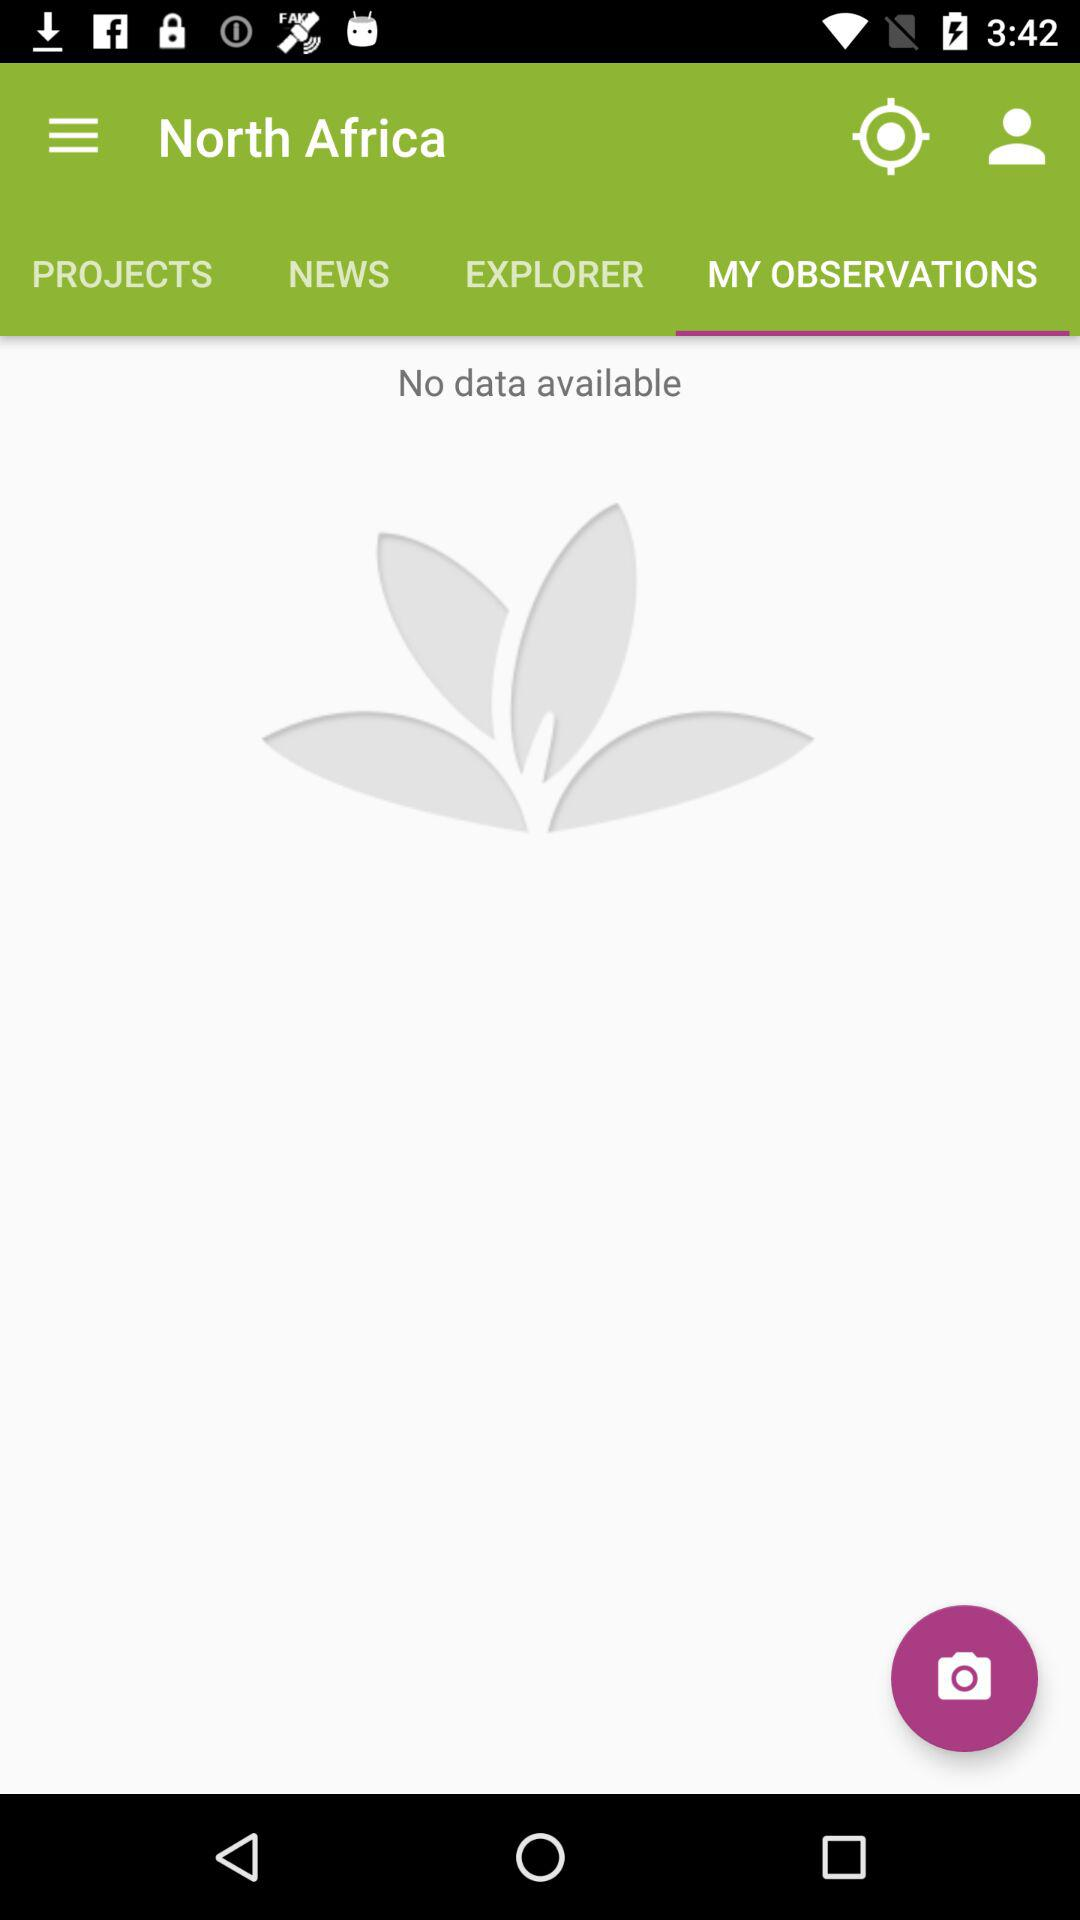What is the name of the user?
When the provided information is insufficient, respond with <no answer>. <no answer> 